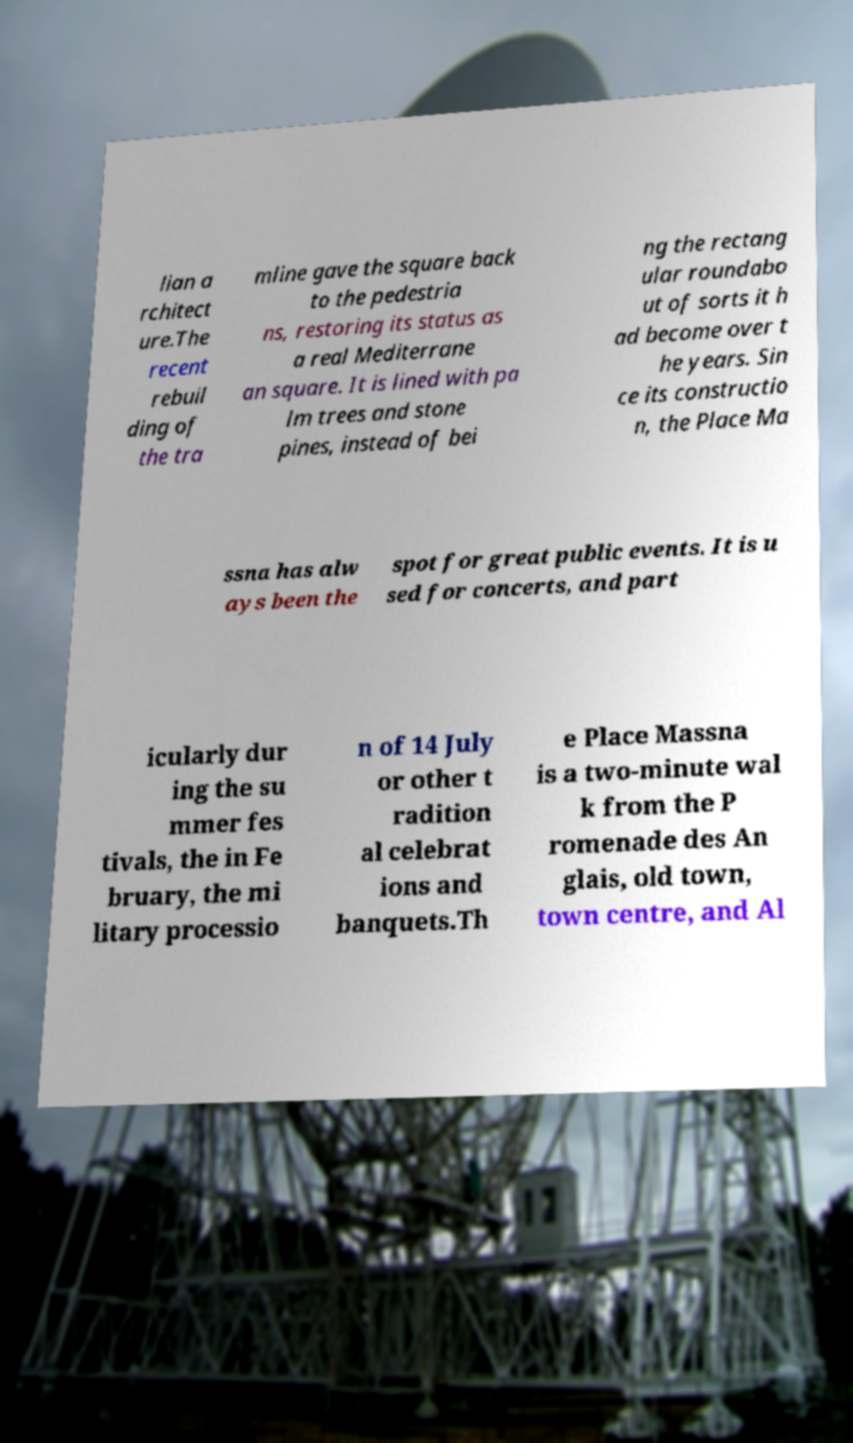Could you extract and type out the text from this image? lian a rchitect ure.The recent rebuil ding of the tra mline gave the square back to the pedestria ns, restoring its status as a real Mediterrane an square. It is lined with pa lm trees and stone pines, instead of bei ng the rectang ular roundabo ut of sorts it h ad become over t he years. Sin ce its constructio n, the Place Ma ssna has alw ays been the spot for great public events. It is u sed for concerts, and part icularly dur ing the su mmer fes tivals, the in Fe bruary, the mi litary processio n of 14 July or other t radition al celebrat ions and banquets.Th e Place Massna is a two-minute wal k from the P romenade des An glais, old town, town centre, and Al 